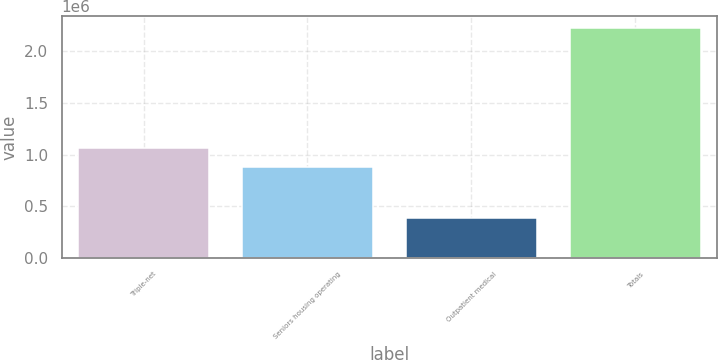Convert chart to OTSL. <chart><loc_0><loc_0><loc_500><loc_500><bar_chart><fcel>Triple-net<fcel>Seniors housing operating<fcel>Outpatient medical<fcel>Totals<nl><fcel>1.06474e+06<fcel>880026<fcel>384068<fcel>2.23118e+06<nl></chart> 